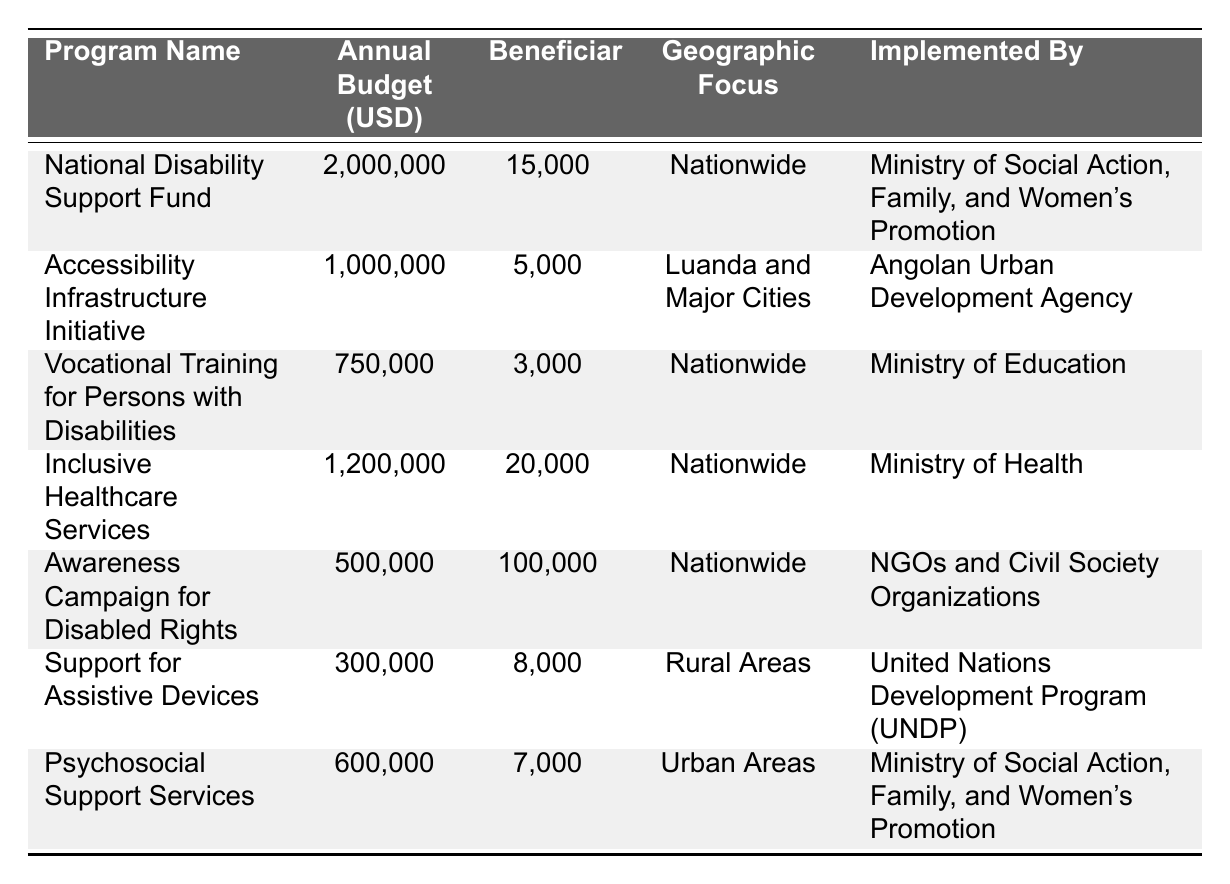What is the annual budget for the National Disability Support Fund? The annual budget for the National Disability Support Fund is clearly stated in the table as 2,000,000 USD.
Answer: 2,000,000 USD How many beneficiaries does the Inclusive Healthcare Services program have? The table specifies that the Inclusive Healthcare Services program has 20,000 beneficiaries.
Answer: 20,000 beneficiaries What is the total annual budget allocated for programs focusing on rural areas? The only program focused on rural areas is the Support for Assistive Devices, with an annual budget of 300,000 USD. Therefore, the total is 300,000 USD.
Answer: 300,000 USD Which program has the highest number of beneficiaries and how many are there? The Awareness Campaign for Disabled Rights has the highest number of beneficiaries listed, which is 100,000.
Answer: 100,000 beneficiaries What is the average annual budget for all disability programs listed? The total annual budget for all programs is (2,000,000 + 1,000,000 + 750,000 + 1,200,000 + 500,000 + 300,000 + 600,000) = 6,350,000 USD. There are 7 programs, so the average budget is 6,350,000 / 7 = 907,143 USD (approximately).
Answer: 907,143 USD Does the Ministry of Health implement any programs listed in the table? Yes, the table indicates that the Ministry of Health implements the Inclusive Healthcare Services program.
Answer: Yes Which program has the least annual budget and what is the budget? The program with the least annual budget is the Support for Assistive Devices, which has a budget of 300,000 USD.
Answer: 300,000 USD What is the total number of beneficiaries across all disability programs? The total number of beneficiaries is calculated by summing the beneficiaries for each program: (15,000 + 5,000 + 3,000 + 20,000 + 100,000 + 8,000 + 7,000) = 158,000 beneficiaries.
Answer: 158,000 beneficiaries Are there any programs specifically focusing on urban areas? Yes, the Psychosocial Support Services program is specifically listed as focusing on urban areas.
Answer: Yes What percentage of the total annual budget is allocated to the Awareness Campaign for Disabled Rights? The Awareness Campaign for Disabled Rights has an annual budget of 500,000 USD. The total budget is 6,350,000 USD. The percentage is (500,000 / 6,350,000) * 100 ≈ 7.87%.
Answer: 7.87% What is the difference in beneficiaries between the National Disability Support Fund and the Vocational Training for Persons with Disabilities? The National Disability Support Fund has 15,000 beneficiaries, while the Vocational Training program has 3,000. The difference is 15,000 - 3,000 = 12,000 beneficiaries.
Answer: 12,000 beneficiaries 